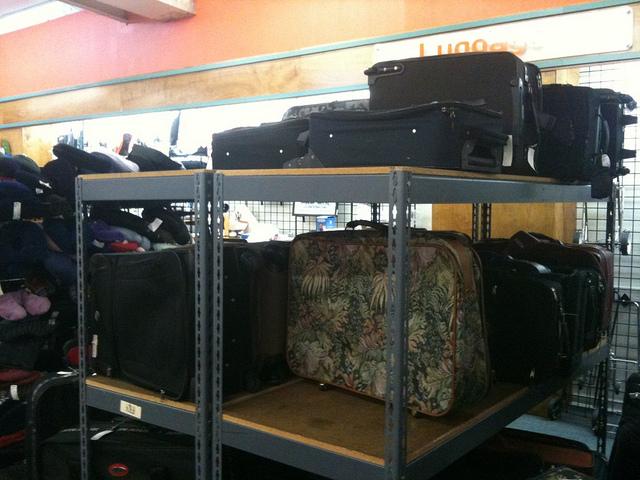Do people use this object to travel with?
Write a very short answer. Yes. Are all of the suitcases black?
Concise answer only. No. How many luggages are on display?
Keep it brief. 11. 